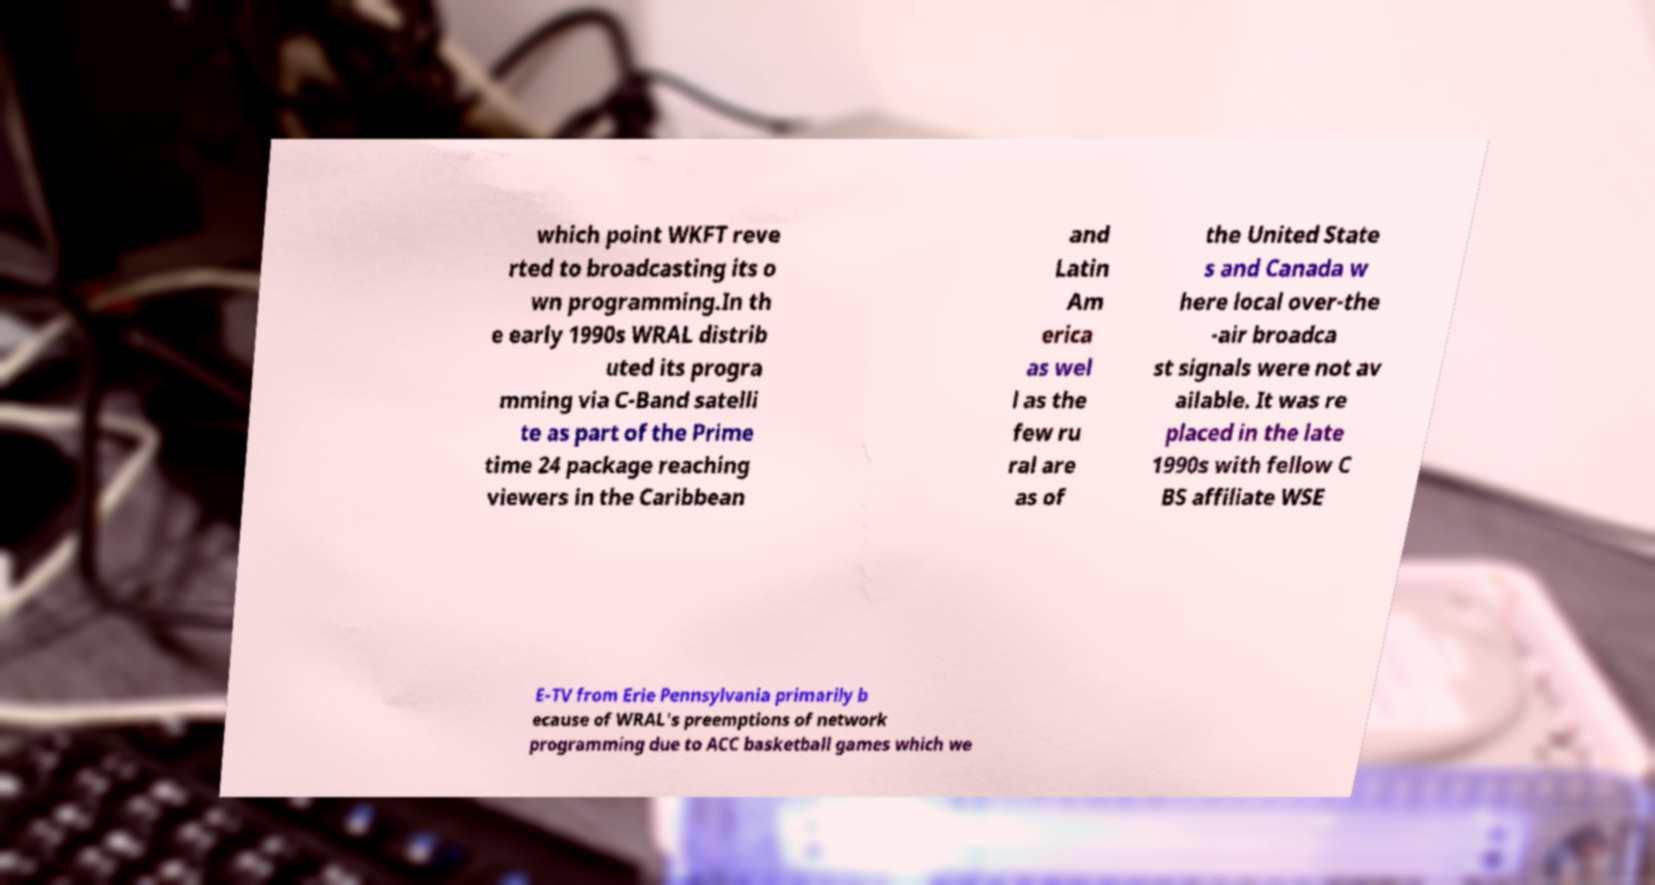What messages or text are displayed in this image? I need them in a readable, typed format. which point WKFT reve rted to broadcasting its o wn programming.In th e early 1990s WRAL distrib uted its progra mming via C-Band satelli te as part of the Prime time 24 package reaching viewers in the Caribbean and Latin Am erica as wel l as the few ru ral are as of the United State s and Canada w here local over-the -air broadca st signals were not av ailable. It was re placed in the late 1990s with fellow C BS affiliate WSE E-TV from Erie Pennsylvania primarily b ecause of WRAL's preemptions of network programming due to ACC basketball games which we 